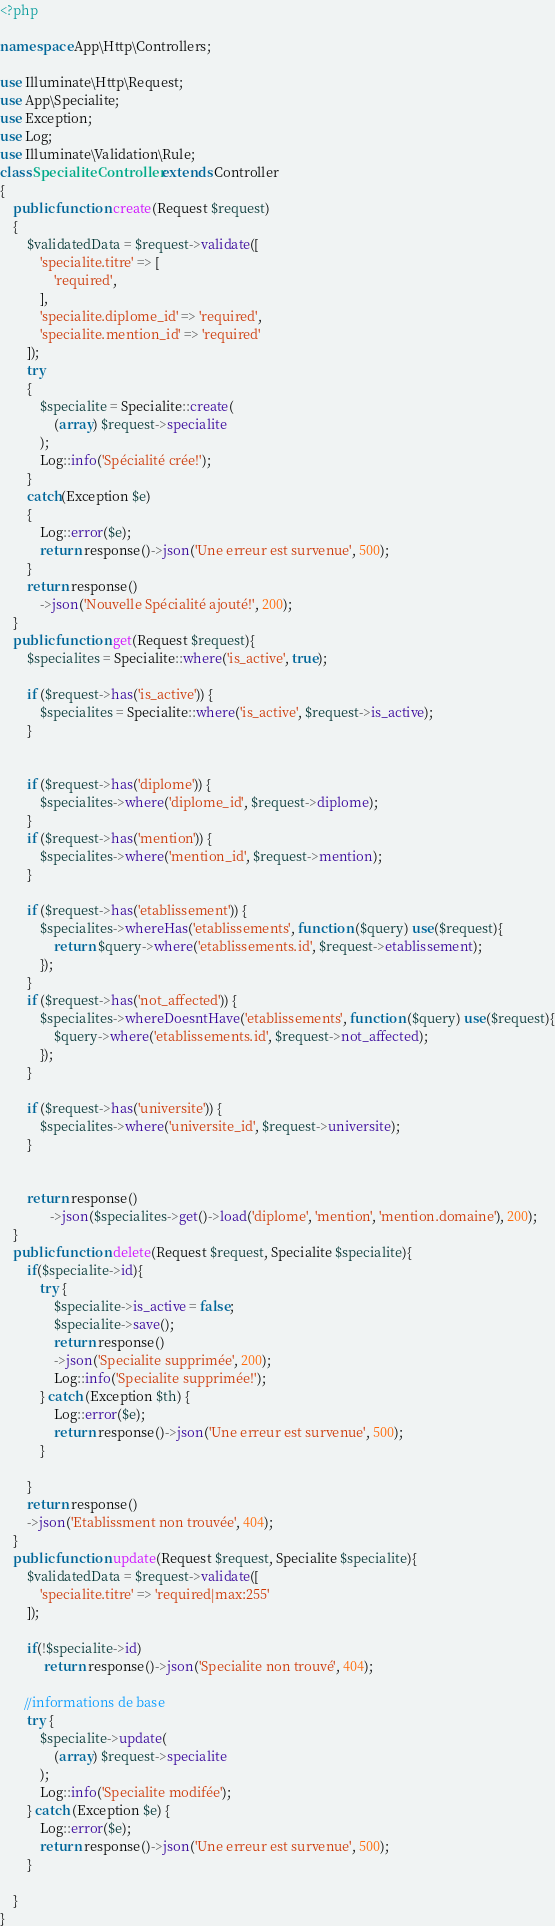Convert code to text. <code><loc_0><loc_0><loc_500><loc_500><_PHP_><?php

namespace App\Http\Controllers;

use Illuminate\Http\Request;
use App\Specialite;
use Exception;
use Log;
use Illuminate\Validation\Rule;
class SpecialiteController extends Controller
{
    public function create(Request $request)
    {
        $validatedData = $request->validate([
            'specialite.titre' => [
                'required', 
            ],
            'specialite.diplome_id' => 'required',
            'specialite.mention_id' => 'required'
        ]);
        try
        {
            $specialite = Specialite::create(
                (array) $request->specialite
            );
            Log::info('Spécialité crée!');
        }
        catch(Exception $e)
        {
            Log::error($e);
            return response()->json('Une erreur est survenue', 500);
        }
        return response()
            ->json('Nouvelle Spécialité ajouté!', 200);
    }
    public function get(Request $request){
        $specialites = Specialite::where('is_active', true);
    
        if ($request->has('is_active')) {
            $specialites = Specialite::where('is_active', $request->is_active);
        }
        
        
        if ($request->has('diplome')) {
            $specialites->where('diplome_id', $request->diplome);
        }  
        if ($request->has('mention')) {
            $specialites->where('mention_id', $request->mention);
        }  

        if ($request->has('etablissement')) {
            $specialites->whereHas('etablissements', function ($query) use($request){
                return $query->where('etablissements.id', $request->etablissement);
            });
        }
        if ($request->has('not_affected')) {
            $specialites->whereDoesntHave('etablissements', function ($query) use($request){
                $query->where('etablissements.id', $request->not_affected);
            });
        }
        
        if ($request->has('universite')) {
            $specialites->where('universite_id', $request->universite);
        }  
        
    
        return response()
               ->json($specialites->get()->load('diplome', 'mention', 'mention.domaine'), 200);
    }
    public function delete(Request $request, Specialite $specialite){
        if($specialite->id){
            try {
                $specialite->is_active = false;
                $specialite->save();
                return response()
                ->json('Specialite supprimée', 200);
                Log::info('Specialite supprimée!');
            } catch (Exception $th) {
                Log::error($e);
                return response()->json('Une erreur est survenue', 500);
            }
    
        }
        return response()
        ->json('Etablissment non trouvée', 404);
    }
    public function update(Request $request, Specialite $specialite){
        $validatedData = $request->validate([
            'specialite.titre' => 'required|max:255'
        ]);
    
        if(!$specialite->id)
             return response()->json('Specialite non trouvé', 404);
    
       //informations de base
        try {
            $specialite->update(
                (array) $request->specialite
            );
            Log::info('Specialite modifée');
        } catch (Exception $e) {
            Log::error($e);
            return response()->json('Une erreur est survenue', 500);
        }
    
    }
}
</code> 